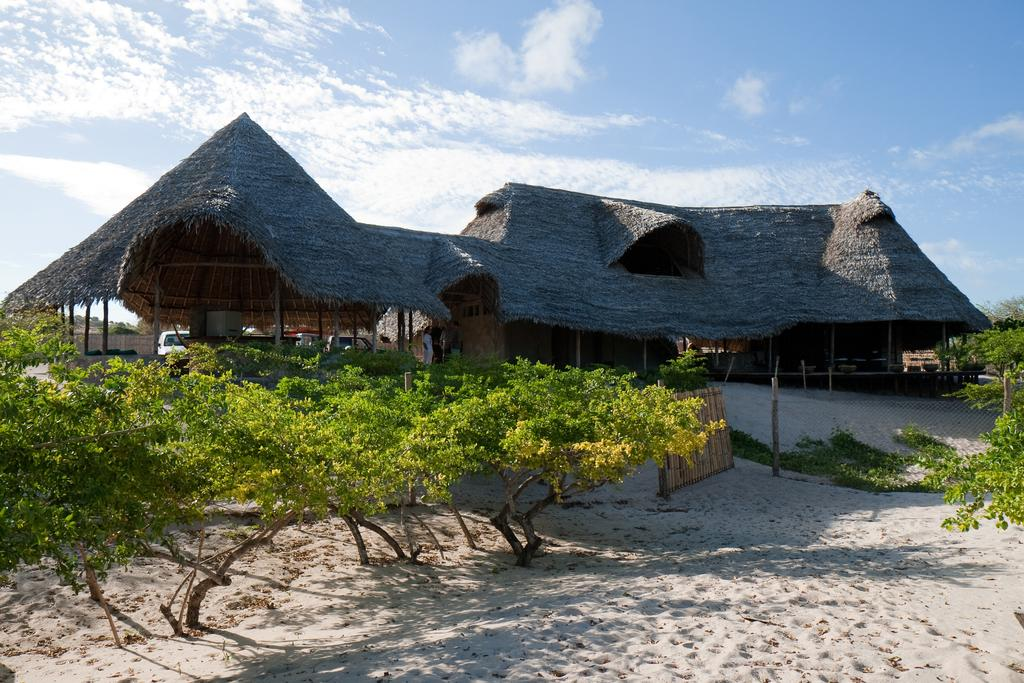What type of structure is present in the image? There is a big shed house in the image. What natural elements can be seen in the image? There are trees and sea sand visible in the image. What is the chin of the brother doing in the image? There is no chin or brother present in the image. 